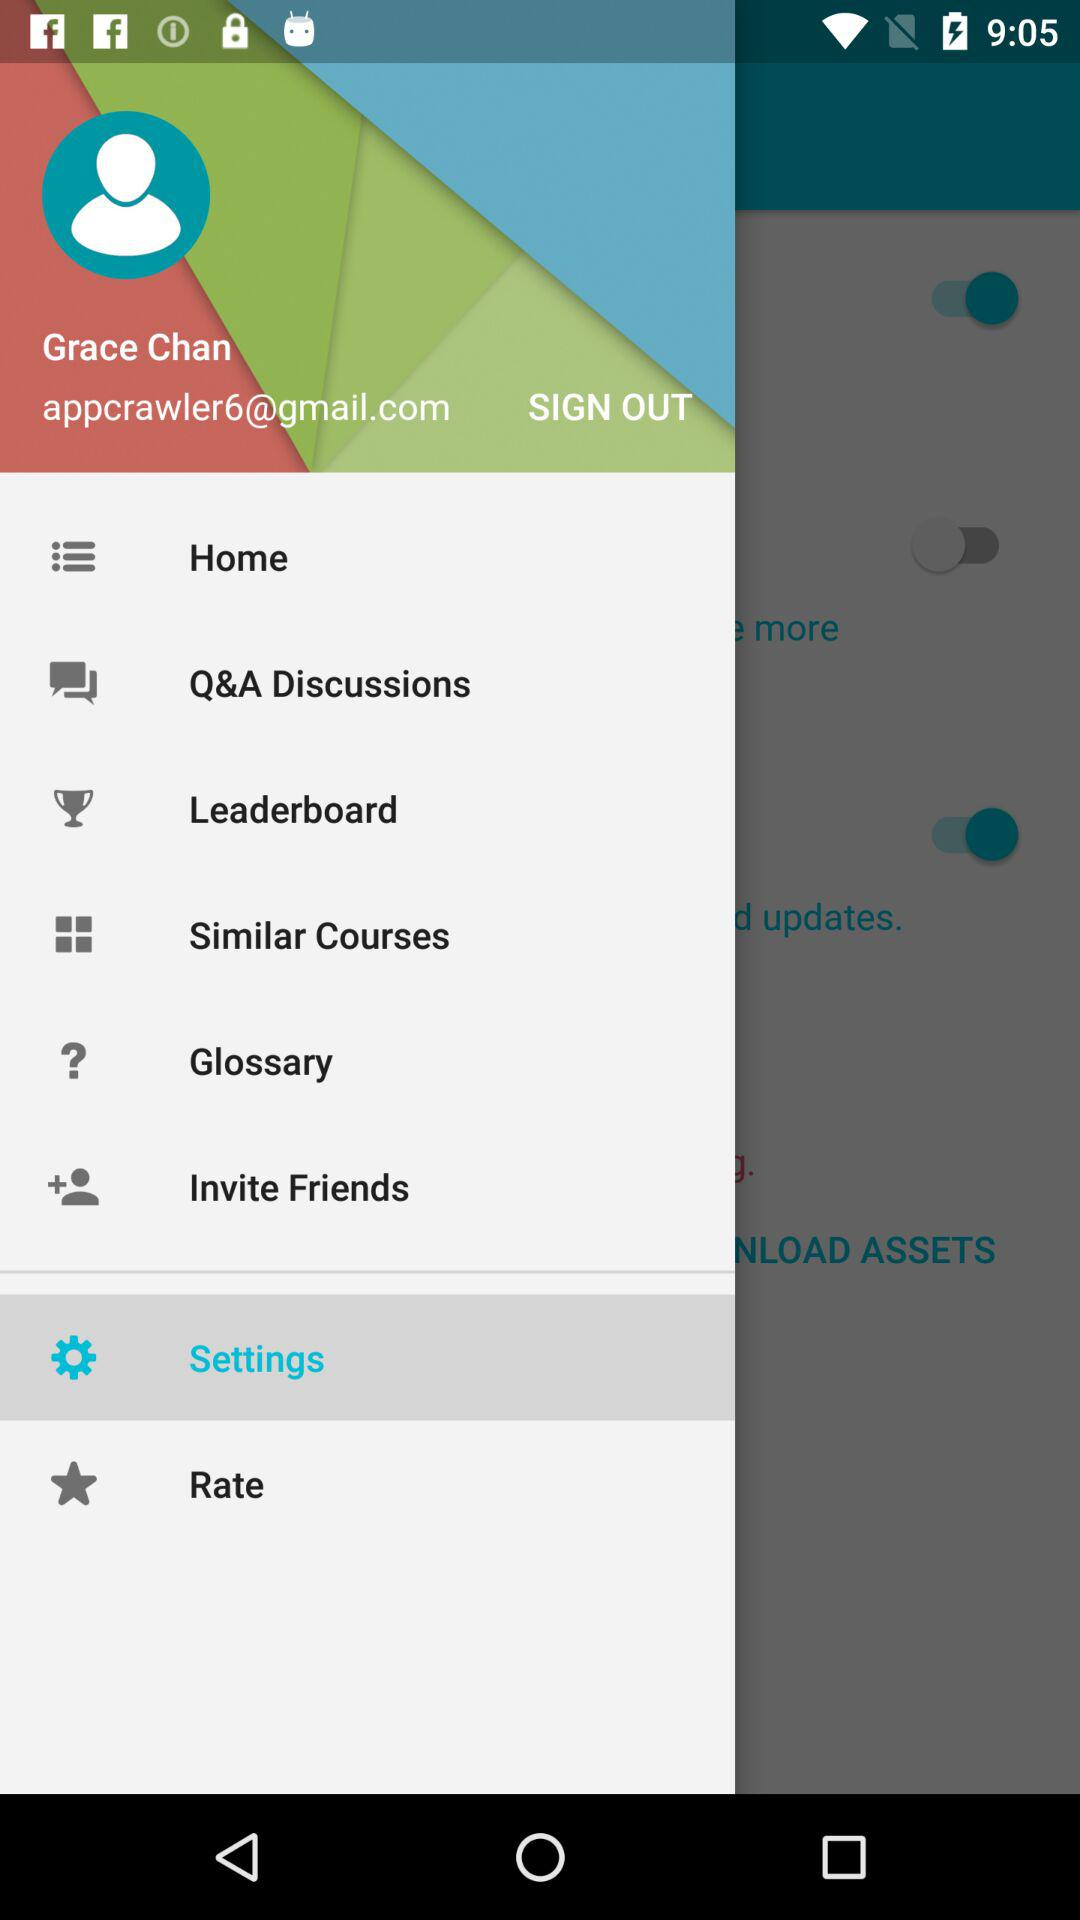What is the email address? The email address is appcrawler6@gmail.com. 